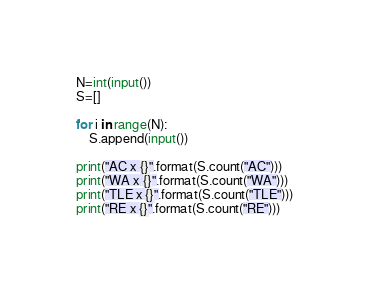<code> <loc_0><loc_0><loc_500><loc_500><_Python_>N=int(input())
S=[]

for i in range(N):
    S.append(input())

print("AC x {}".format(S.count("AC")))
print("WA x {}".format(S.count("WA")))
print("TLE x {}".format(S.count("TLE")))
print("RE x {}".format(S.count("RE")))</code> 